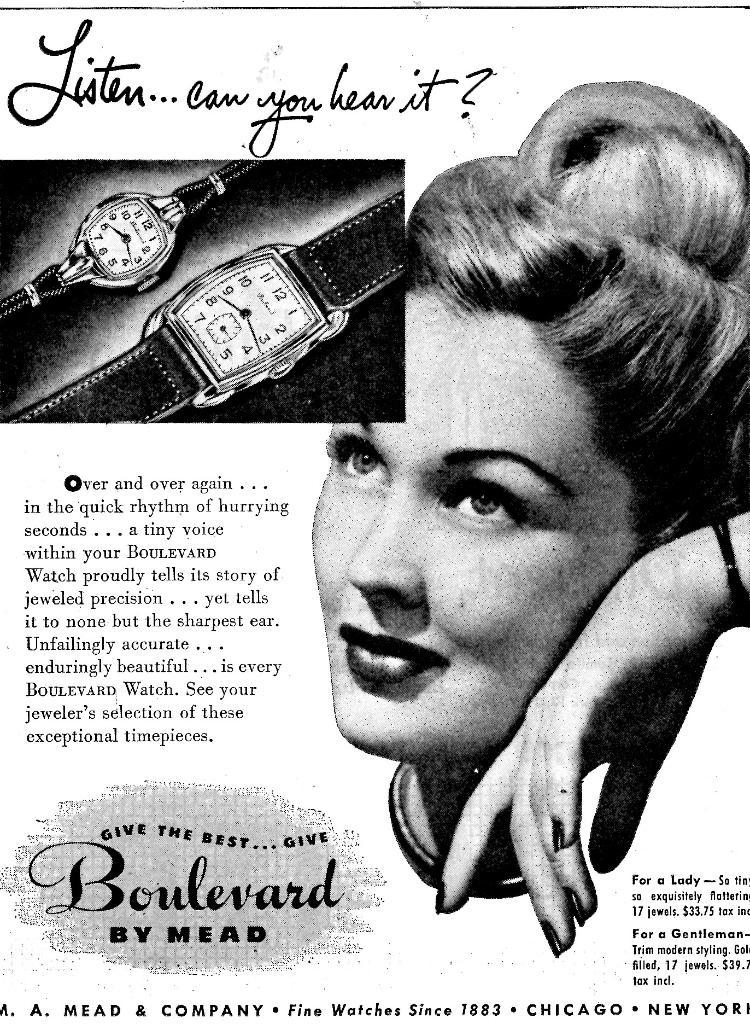<image>
Summarize the visual content of the image. An ad shows a woman with the tagline of "Listen, can you hear it?" 